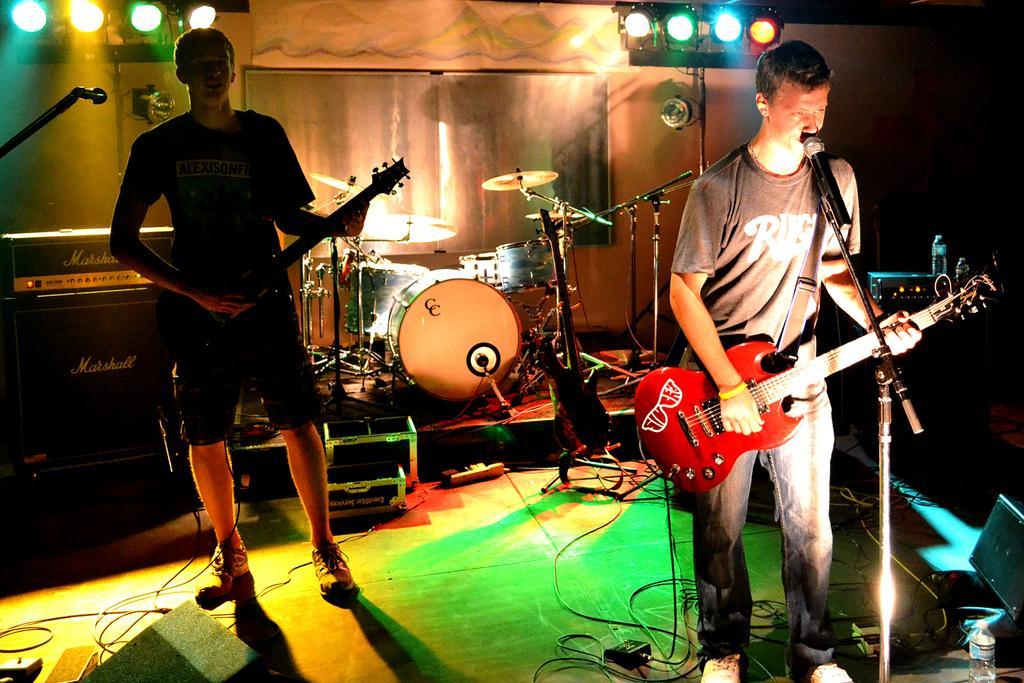Can you describe this image briefly? In the image we can see there are people who are standing and holding guitar in their hand and at the back there are other musical instruments. 